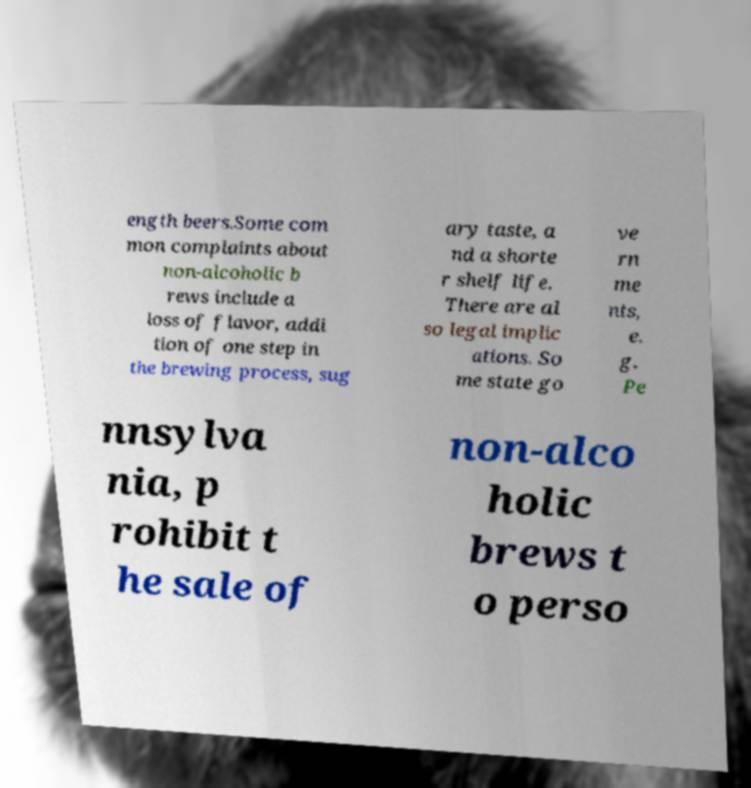I need the written content from this picture converted into text. Can you do that? ength beers.Some com mon complaints about non-alcoholic b rews include a loss of flavor, addi tion of one step in the brewing process, sug ary taste, a nd a shorte r shelf life. There are al so legal implic ations. So me state go ve rn me nts, e. g. Pe nnsylva nia, p rohibit t he sale of non-alco holic brews t o perso 